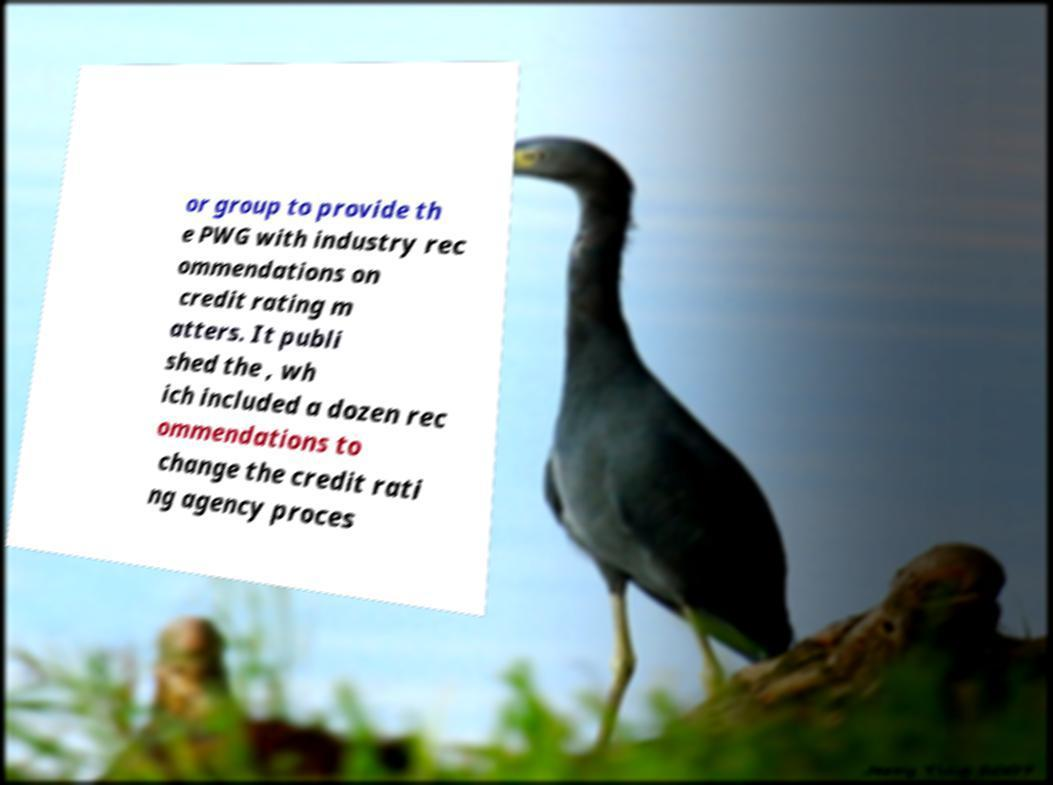What messages or text are displayed in this image? I need them in a readable, typed format. or group to provide th e PWG with industry rec ommendations on credit rating m atters. It publi shed the , wh ich included a dozen rec ommendations to change the credit rati ng agency proces 